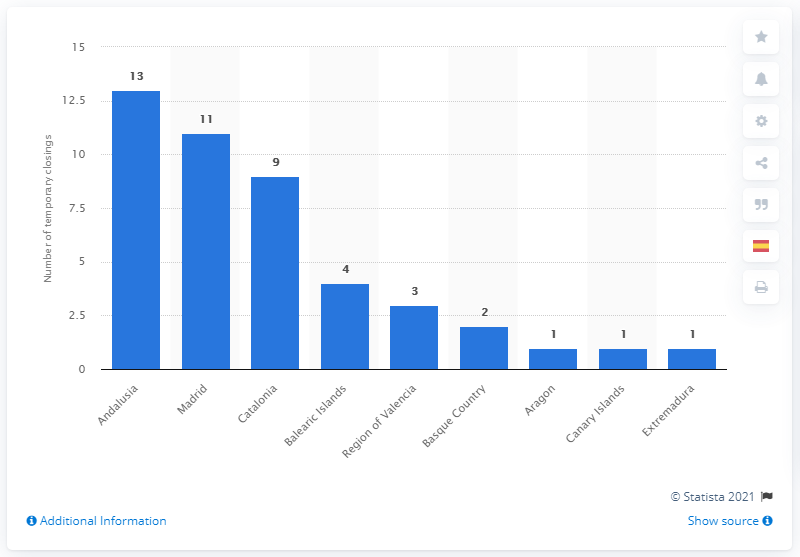Outline some significant characteristics in this image. Meli Hotels International's hotels were primarily located in Andalusia. 